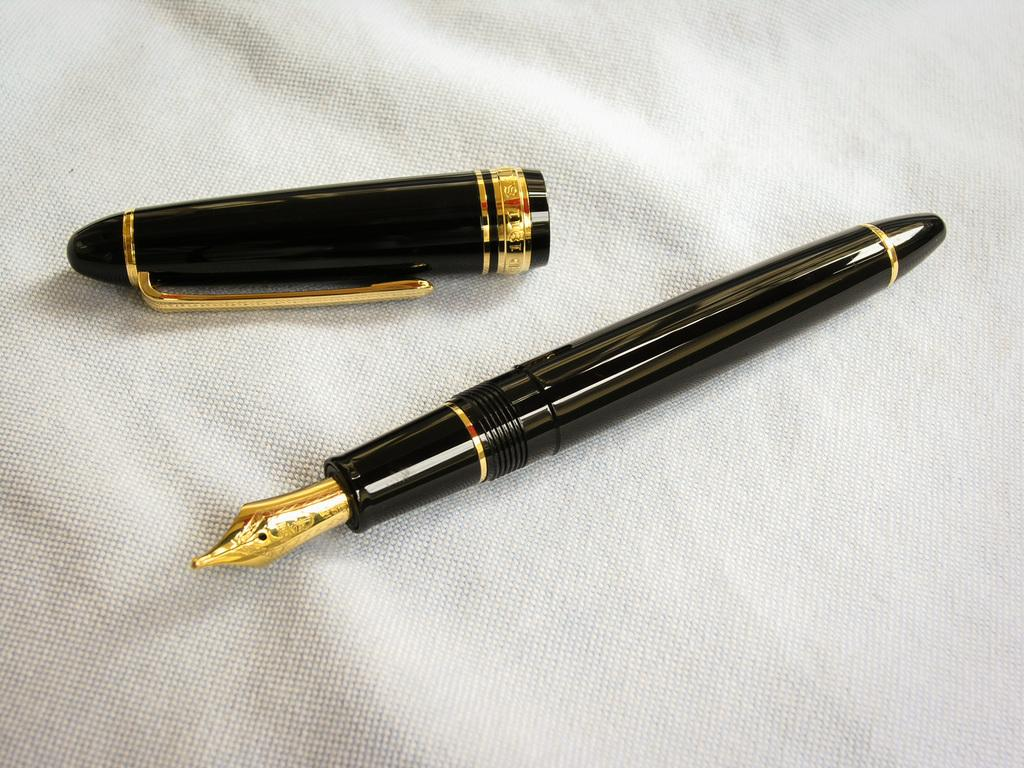What object is present in the image that is commonly used for writing? There is a pen in the image. What part of the pen is also visible in the image? There is a pen cap in the image. On what surface are the pen and pen cap placed? The pen and pen cap are on a cloth. How many brothers are depicted wearing vests in the image? There are no brothers or vests present in the image; it only features a pen, pen cap, and a cloth. 